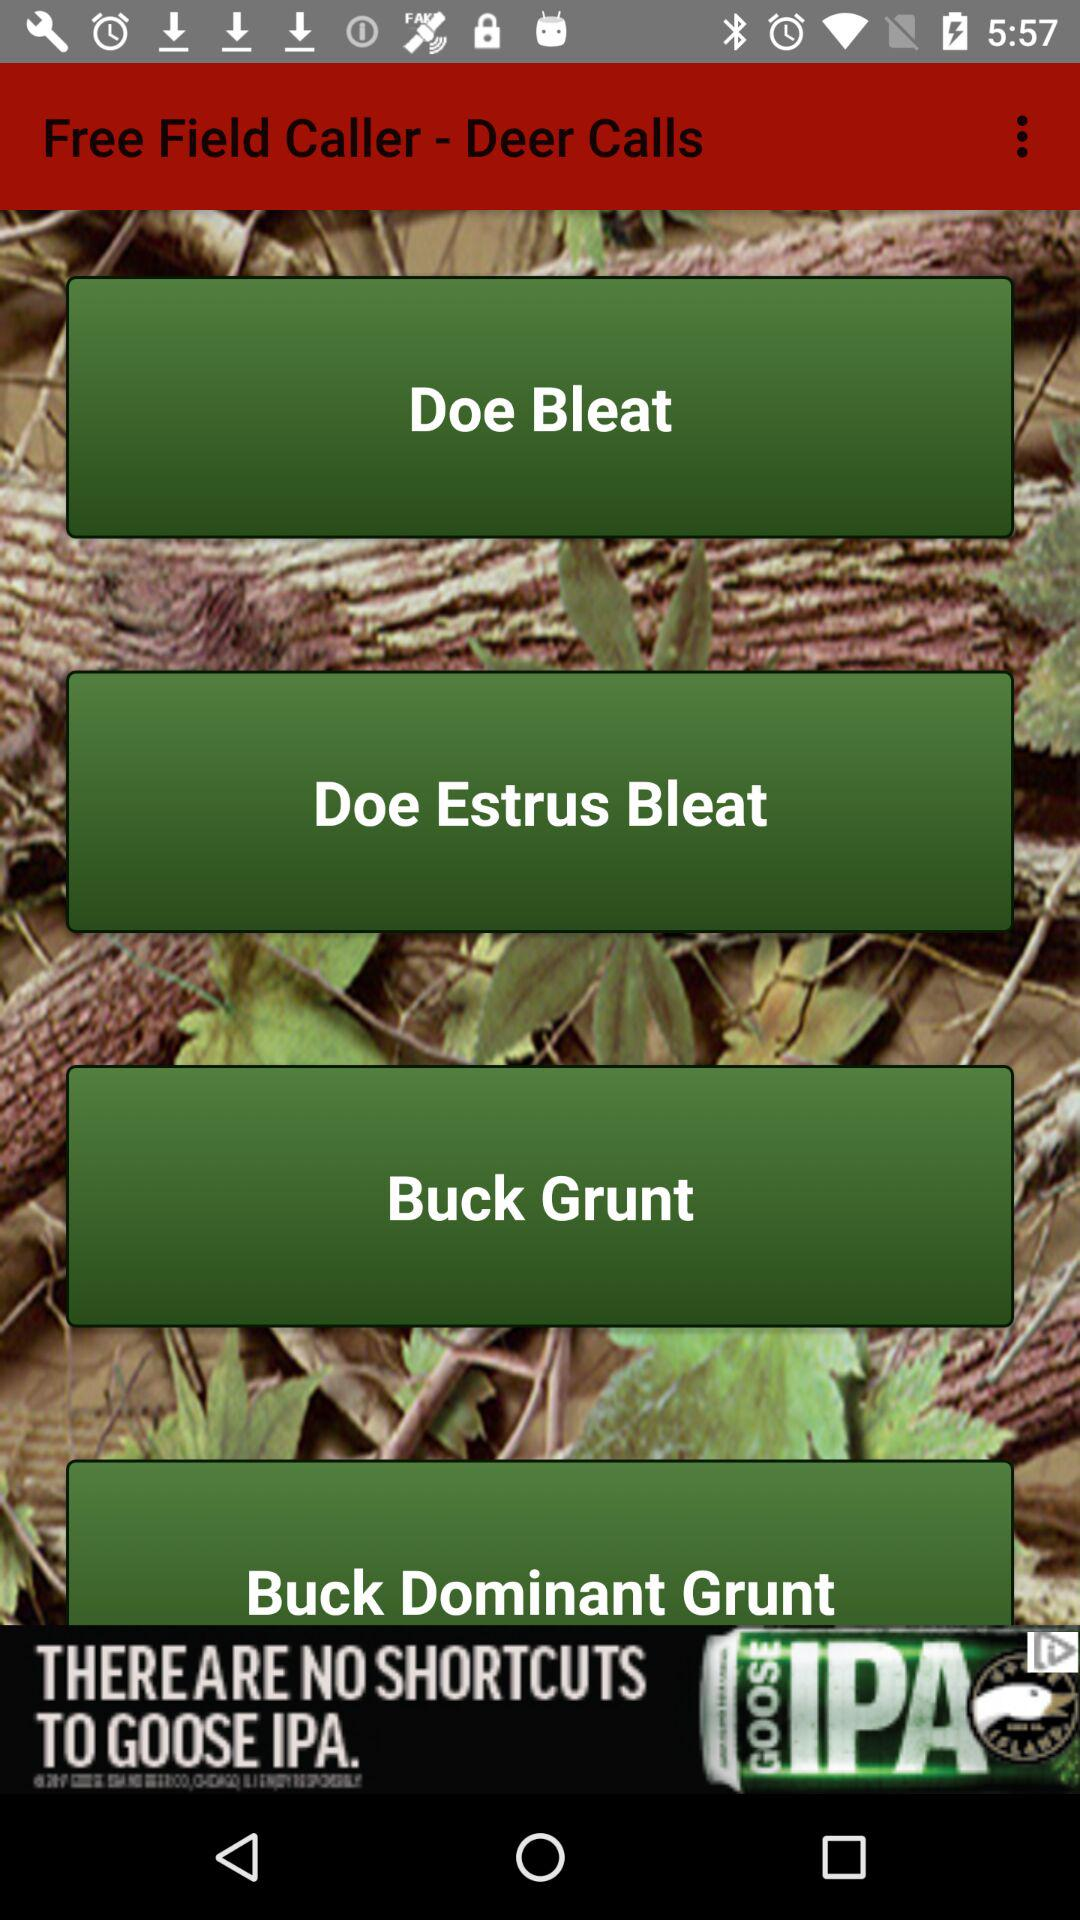How many deer calls are available?
When the provided information is insufficient, respond with <no answer>. <no answer> 